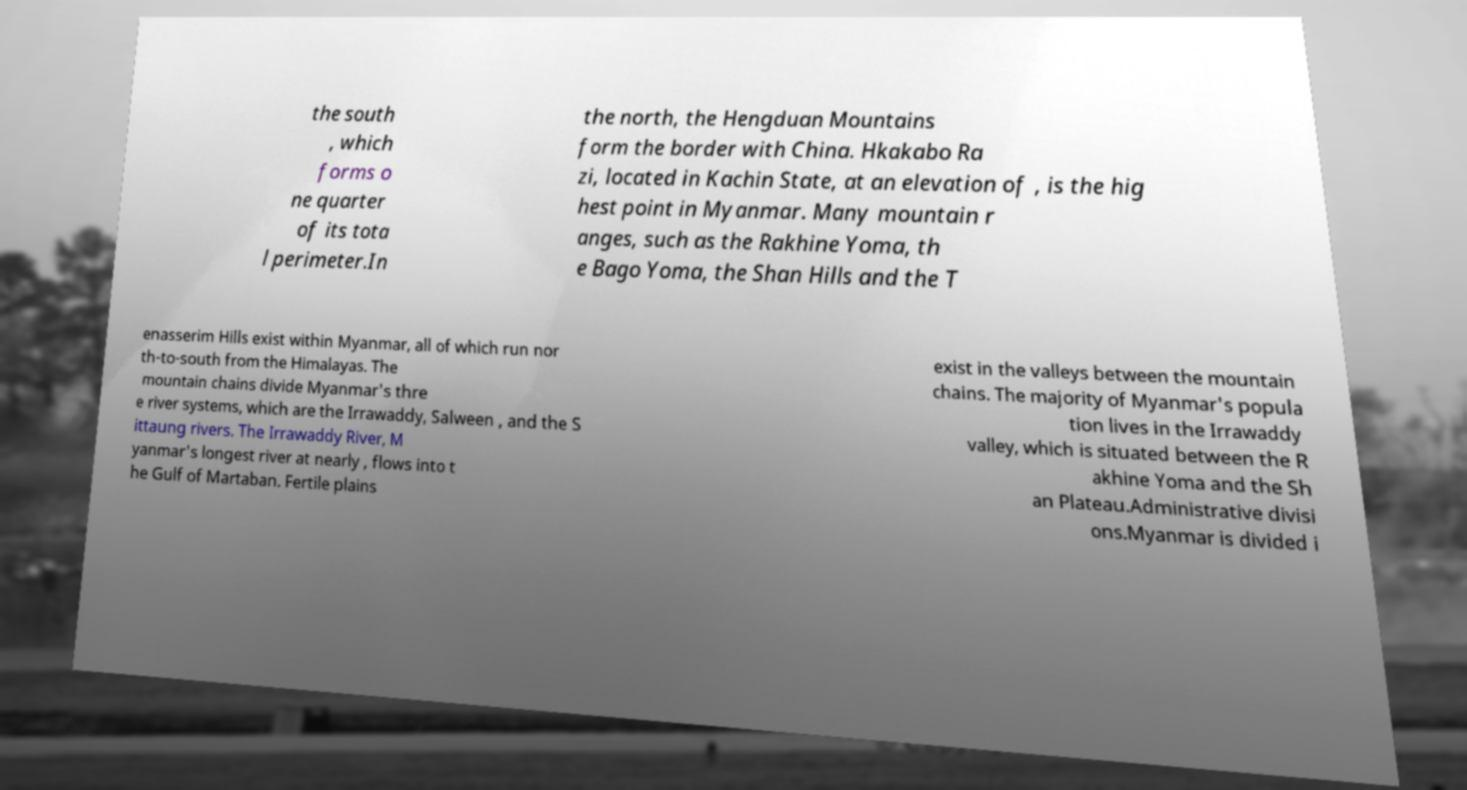Can you accurately transcribe the text from the provided image for me? the south , which forms o ne quarter of its tota l perimeter.In the north, the Hengduan Mountains form the border with China. Hkakabo Ra zi, located in Kachin State, at an elevation of , is the hig hest point in Myanmar. Many mountain r anges, such as the Rakhine Yoma, th e Bago Yoma, the Shan Hills and the T enasserim Hills exist within Myanmar, all of which run nor th-to-south from the Himalayas. The mountain chains divide Myanmar's thre e river systems, which are the Irrawaddy, Salween , and the S ittaung rivers. The Irrawaddy River, M yanmar's longest river at nearly , flows into t he Gulf of Martaban. Fertile plains exist in the valleys between the mountain chains. The majority of Myanmar's popula tion lives in the Irrawaddy valley, which is situated between the R akhine Yoma and the Sh an Plateau.Administrative divisi ons.Myanmar is divided i 